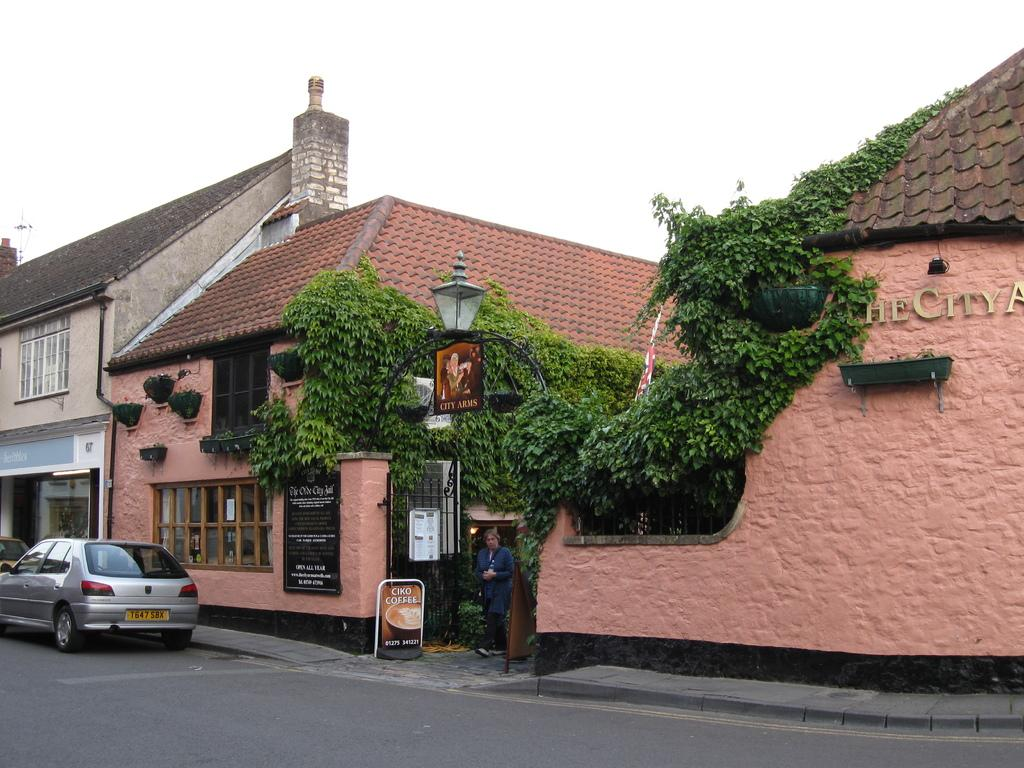What can be seen in the foreground of the image? In the foreground of the image, there are buildings, boards, creepers, houseplants, and vehicles on the road. What is visible in the background of the image? The sky is visible in the background of the image. Can you describe the time of day when the image might have been taken? The image might have been taken during the day, as there is no indication of darkness or artificial lighting. How many plants are turning around in the image? There are no plants turning around in the image. What is the size of the largest vehicle in the image? The size of the largest vehicle cannot be determined from the image alone, as there is no reference for scale. 